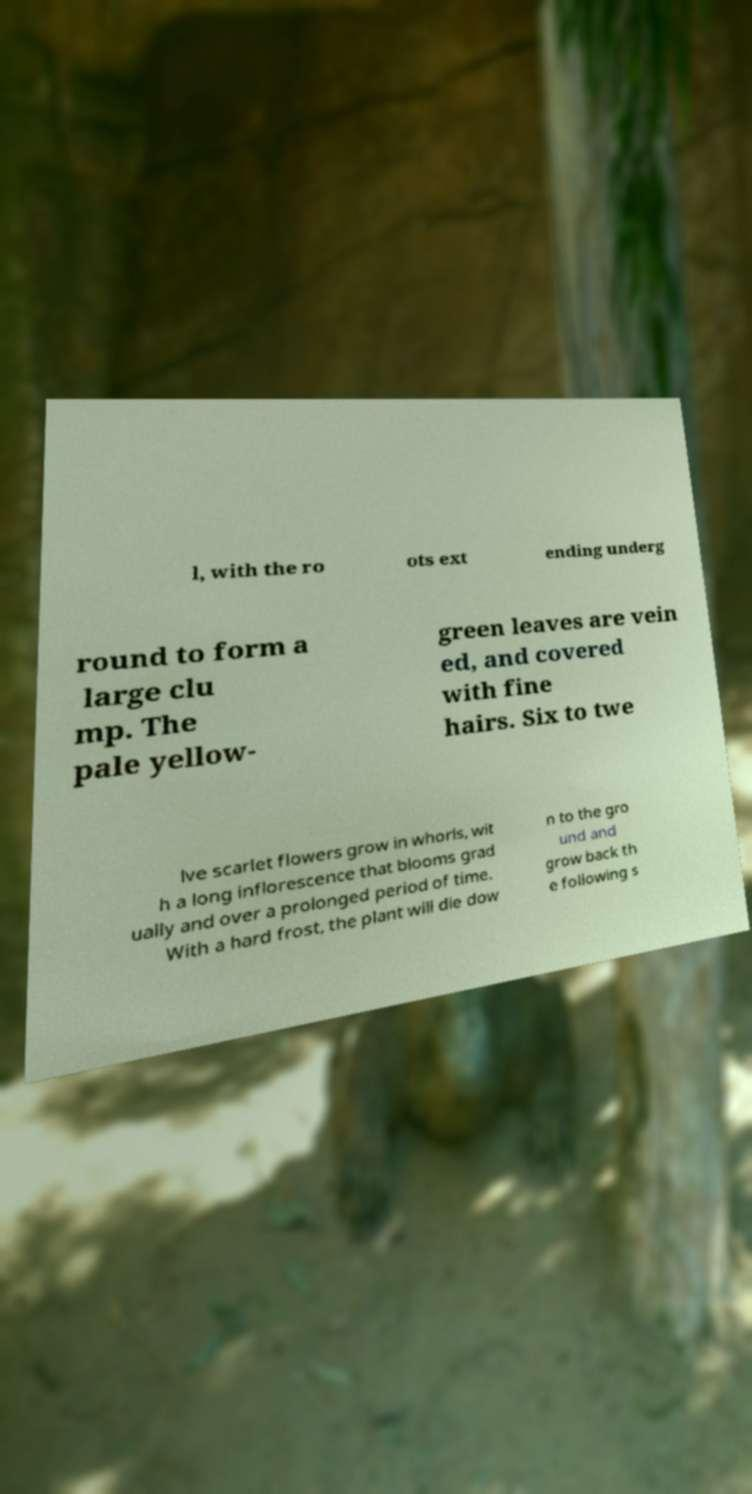Please read and relay the text visible in this image. What does it say? l, with the ro ots ext ending underg round to form a large clu mp. The pale yellow- green leaves are vein ed, and covered with fine hairs. Six to twe lve scarlet flowers grow in whorls, wit h a long inflorescence that blooms grad ually and over a prolonged period of time. With a hard frost, the plant will die dow n to the gro und and grow back th e following s 